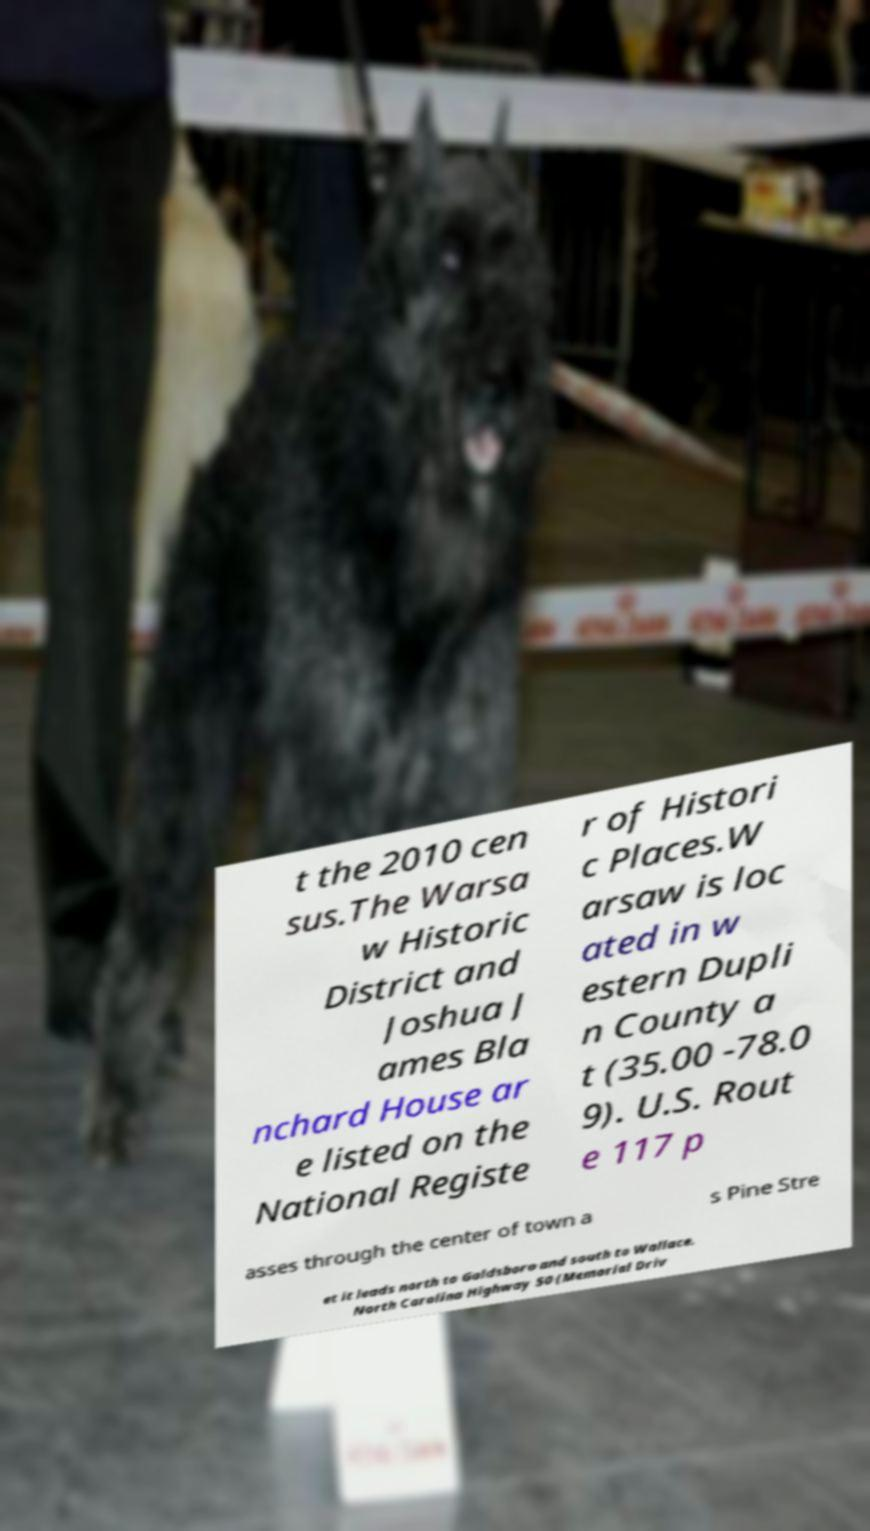Can you read and provide the text displayed in the image?This photo seems to have some interesting text. Can you extract and type it out for me? t the 2010 cen sus.The Warsa w Historic District and Joshua J ames Bla nchard House ar e listed on the National Registe r of Histori c Places.W arsaw is loc ated in w estern Dupli n County a t (35.00 -78.0 9). U.S. Rout e 117 p asses through the center of town a s Pine Stre et it leads north to Goldsboro and south to Wallace. North Carolina Highway 50 (Memorial Driv 